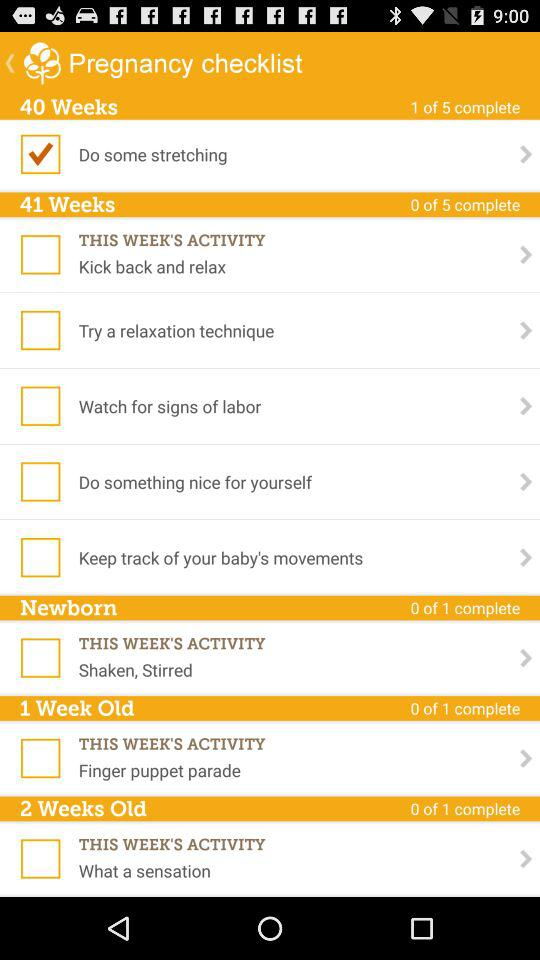What is the name of the application? The name of the application is "Pregnancy checklist". 